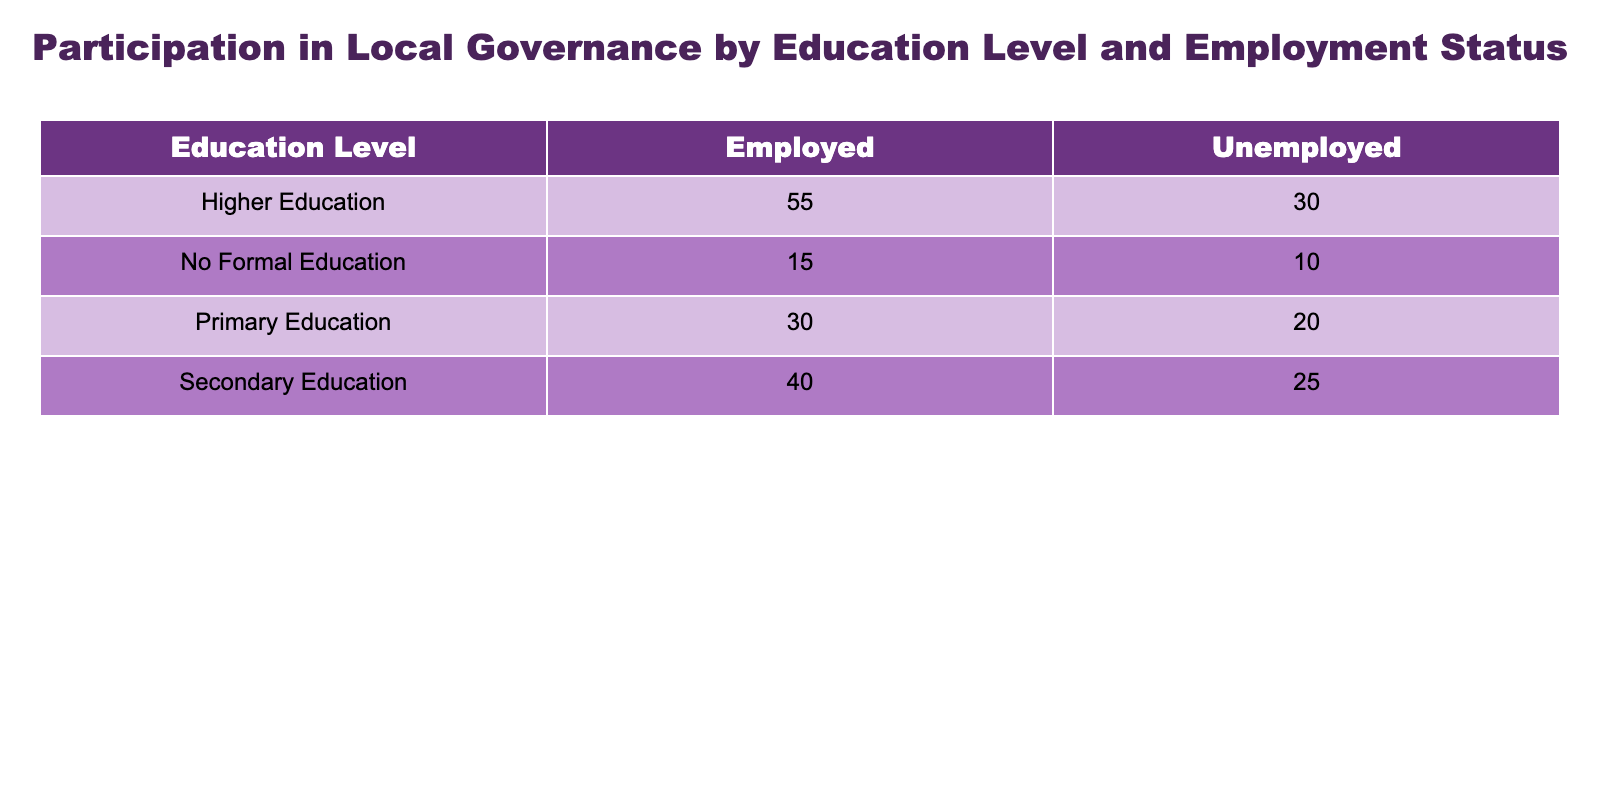What is the participation rate for individuals with no formal education who are unemployed? According to the table, the participation rate for individuals with no formal education and unemployed status is directly listed as 10%.
Answer: 10% What is the participation rate for employed individuals with higher education? The table indicates that the participation rate for employed individuals with higher education is 55%.
Answer: 55% Which education level has the highest participation rate among the unemployed? By comparing the participation rates for the unemployed across all education levels, we find that higher education has the highest participation rate at 30%.
Answer: Higher Education What is the difference in participation rates between employed and unemployed individuals with primary education? The participation rate for unemployed individuals with primary education is 20%, while for employed individuals it is 30%. The difference is calculated as 30 - 20 = 10.
Answer: 10 Are unemployed individuals with secondary education more likely to participate in local governance compared to those with no formal education? Yes, the participation rate for unemployed individuals with secondary education is 25%, which is higher than the 10% for those with no formal education.
Answer: Yes What is the average participation rate for employed individuals across all education levels? To find the average, we sum the participation rates for employed individuals: 15 (no formal education) + 30 (primary education) + 40 (secondary education) + 55 (higher education) = 140. Dividing by the number of data points (4) gives us an average of 35.
Answer: 35 Which education level shows the largest increase in participation rate when comparing unemployed and employed individuals? For each education level, the difference between the employed and unemployed rates is calculated as follows: No Formal Education (15 - 10 = 5), Primary Education (30 - 20 = 10), Secondary Education (40 - 25 = 15), Higher Education (55 - 30 = 25). The largest increase is 25, seen in those with higher education.
Answer: Higher Education Is the participation rate for unemployed individuals with secondary education greater than or equal to the participation rate for employed individuals with primary education? The participation rate for unemployed individuals with secondary education is 25%, while for employed individuals with primary education it is 30%. Since 25 is not greater than or equal to 30, the statement is false.
Answer: No Based on the data, how many total participants can be expected from employed individuals across all educational levels? We sum the participation rates for employed individuals in each category: 15 (no formal education) + 30 (primary education) + 40 (secondary education) + 55 (higher education) = 140%. This implies that if we consider percentage participation as representative of participants, total expected can be interpreted in a sensible context. However, strictly in numbers, it's a percentage representation rather than actual countable participants.
Answer: 140% 